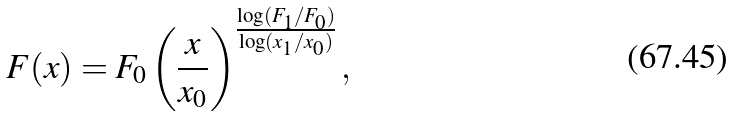<formula> <loc_0><loc_0><loc_500><loc_500>F ( x ) = { F _ { 0 } } \left ( { \frac { x } { x _ { 0 } } } \right ) ^ { \frac { \log ( F _ { 1 } / F _ { 0 } ) } { \log ( x _ { 1 } / x _ { 0 } ) } } ,</formula> 